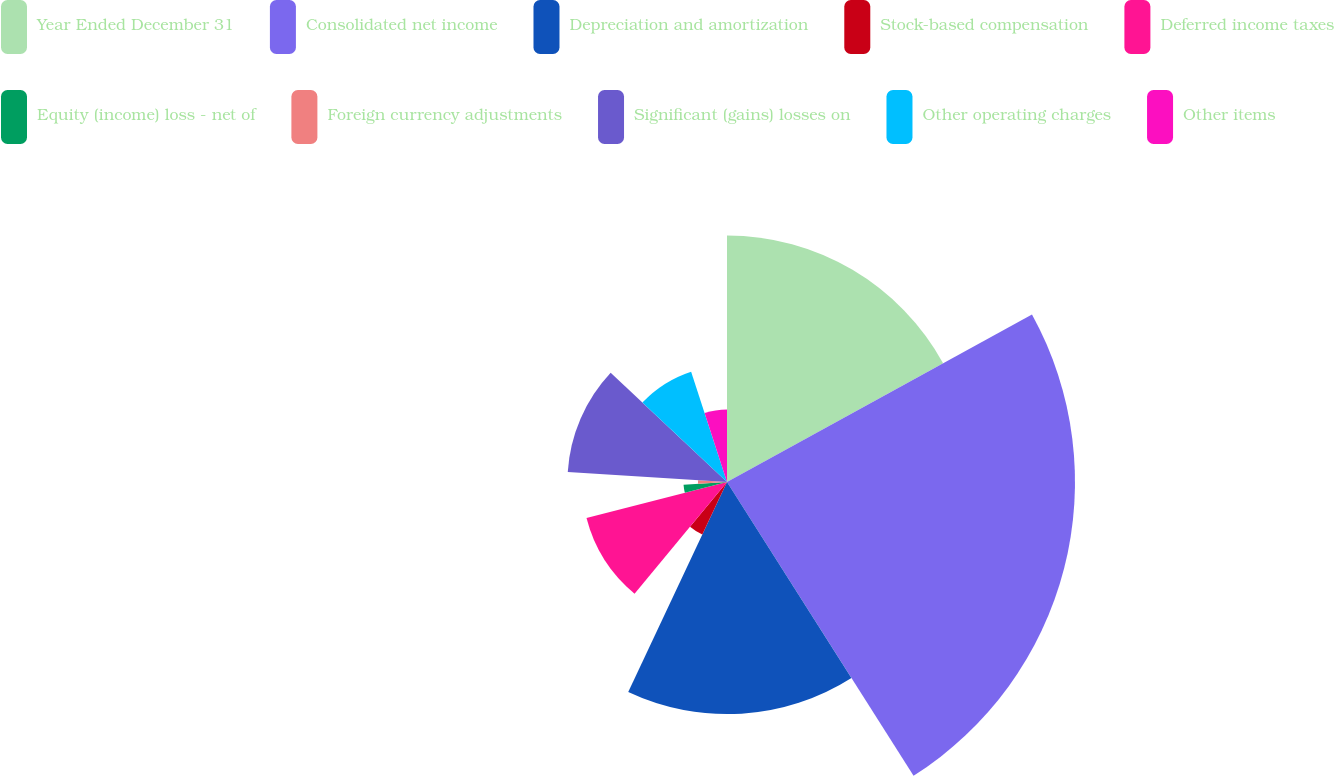Convert chart. <chart><loc_0><loc_0><loc_500><loc_500><pie_chart><fcel>Year Ended December 31<fcel>Consolidated net income<fcel>Depreciation and amortization<fcel>Stock-based compensation<fcel>Deferred income taxes<fcel>Equity (income) loss - net of<fcel>Foreign currency adjustments<fcel>Significant (gains) losses on<fcel>Other operating charges<fcel>Other items<nl><fcel>17.0%<fcel>23.99%<fcel>16.0%<fcel>4.0%<fcel>10.0%<fcel>3.0%<fcel>2.0%<fcel>11.0%<fcel>8.0%<fcel>5.0%<nl></chart> 